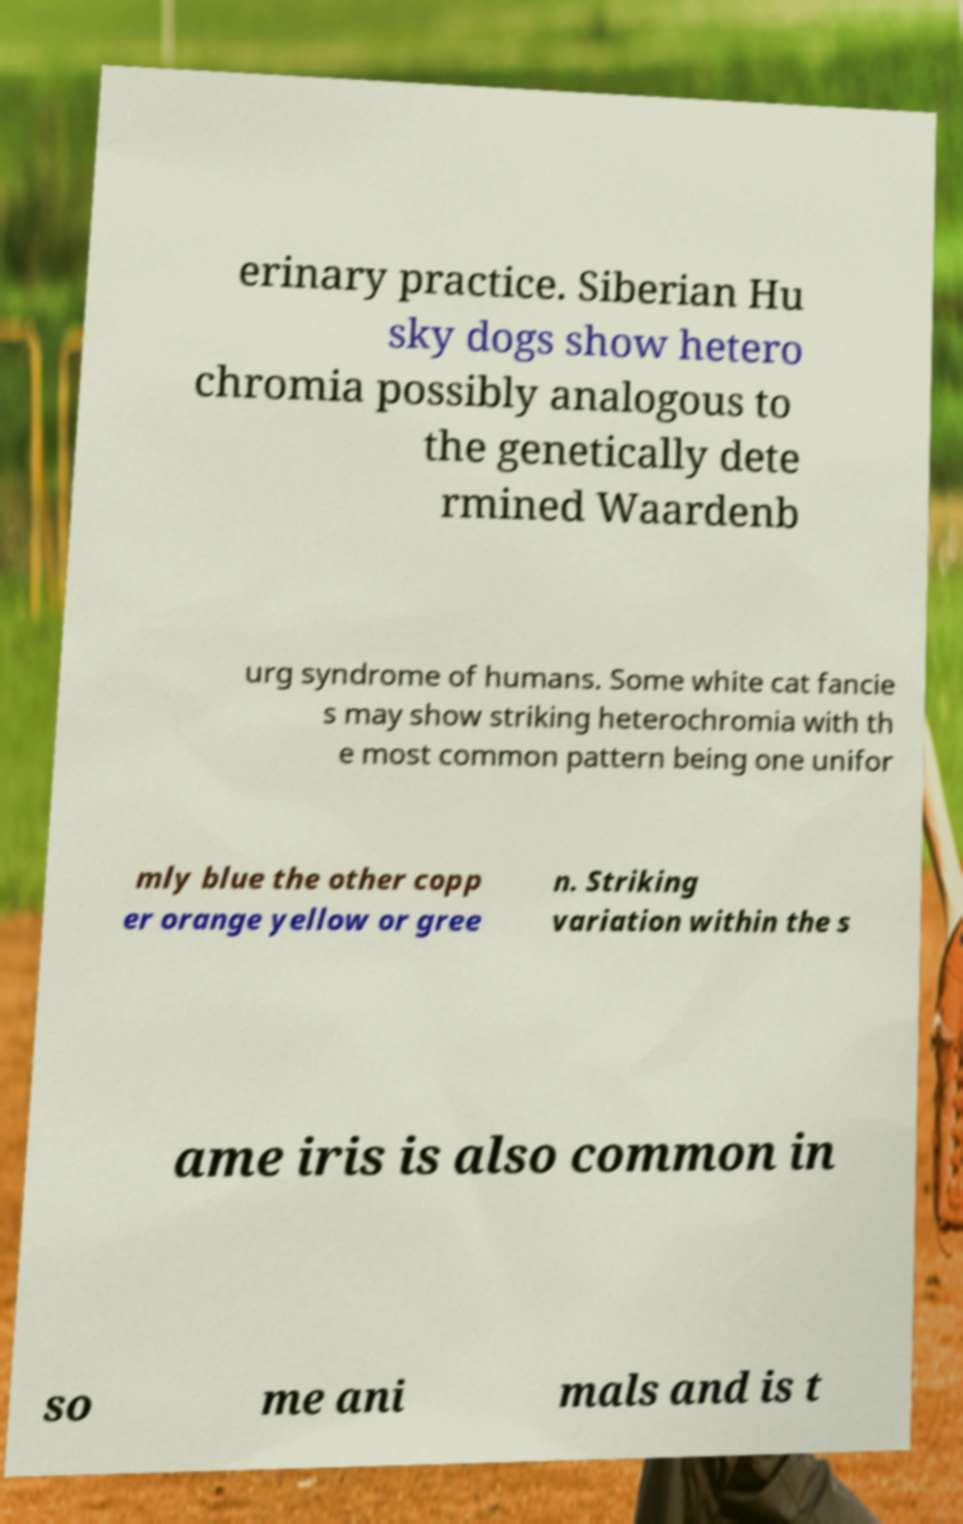I need the written content from this picture converted into text. Can you do that? erinary practice. Siberian Hu sky dogs show hetero chromia possibly analogous to the genetically dete rmined Waardenb urg syndrome of humans. Some white cat fancie s may show striking heterochromia with th e most common pattern being one unifor mly blue the other copp er orange yellow or gree n. Striking variation within the s ame iris is also common in so me ani mals and is t 